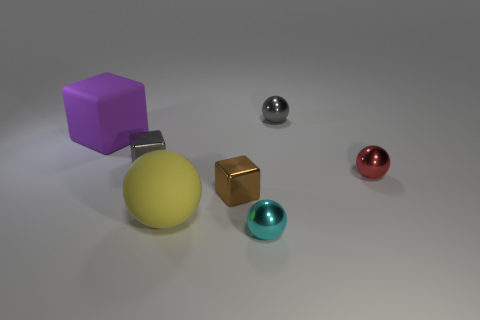Add 3 tiny green metallic cylinders. How many objects exist? 10 Subtract all cubes. How many objects are left? 4 Subtract all tiny red rubber balls. Subtract all shiny blocks. How many objects are left? 5 Add 2 large yellow objects. How many large yellow objects are left? 3 Add 2 brown rubber blocks. How many brown rubber blocks exist? 2 Subtract 0 cyan cubes. How many objects are left? 7 